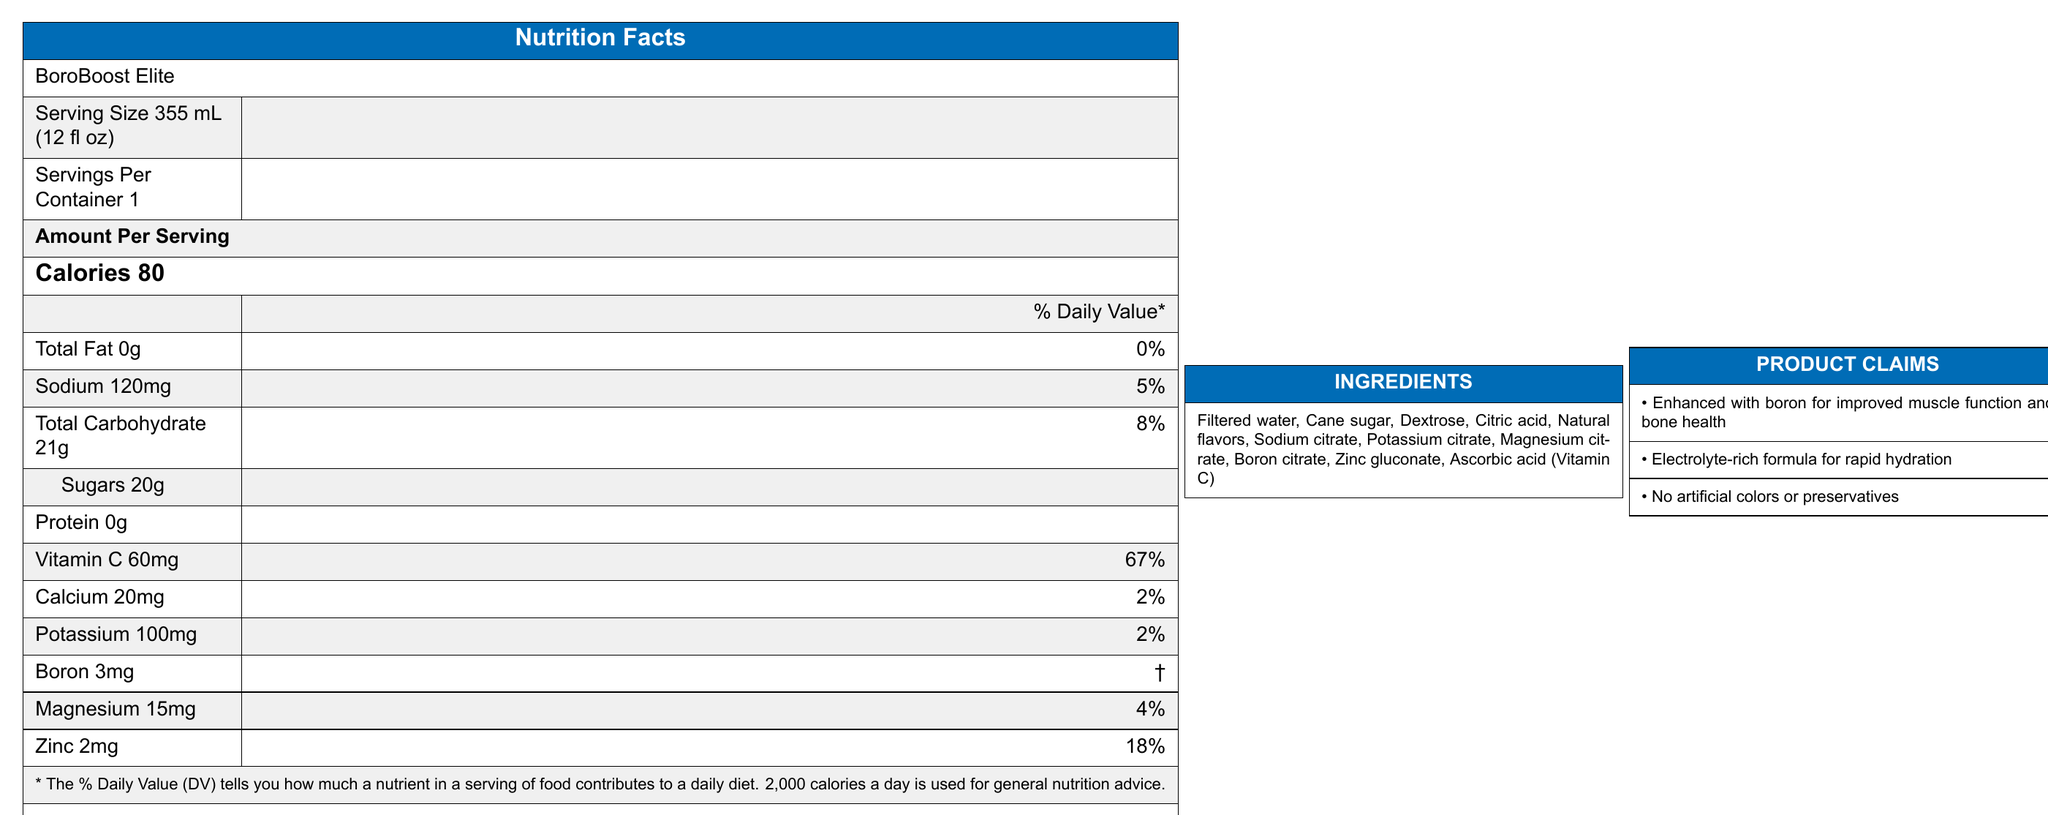what is the serving size for BoroBoost Elite? The serving size is explicitly stated as "Serving Size 355 mL (12 fl oz)" in the label.
Answer: 355 mL (12 fl oz) how many calories are there per serving? The label shows "Calories 80" under the "Amount Per Serving" section.
Answer: 80 calories what percentage of the Daily Value for sodium does one serving contain? The "Sodium 120mg" section lists "5%" as the Daily Value percentage.
Answer: 5% which mineral in BoroBoost Elite does not have an established Daily Value? A. Boron B. Magnesium C. Zinc D. Calcium The label indicates a "†" next to Boron 3mg, which is described as "Daily Value not established".
Answer: A. Boron how much vitamin C is in one serving? The label lists "Vitamin C 60mg" under the nutrients section.
Answer: 60mg does BoroBoost Elite contain any artificial colors? One of the product claims explicitly states "No artificial colors."
Answer: No what ingredients contribute to the electrolytes in the drink? The ingredients list includes electrolytes like sodium citrate, potassium citrate, and magnesium citrate.
Answer: Sodium citrate, Potassium citrate, Magnesium citrate which nutrient contributes the highest percentage of the Daily Value? A. Sodium B. Vitamin C C. Magnesium D. Zinc Vitamin C contributes 67% of the Daily Value, which is the highest among the listed nutrients.
Answer: B. Vitamin C is BoroBoost Elite FDA compliant? The regulatory compliance section states that it is "Compliant with FDA labeling requirements."
Answer: Yes describe the main features of the BoroBoost Elite label. The document details various features of BoroBoost Elite, including nutritional content, ingredients, product claims, and regulatory compliance.
Answer: BoroBoost Elite is a boron-enriched sports drink with a serving size of 355 mL, containing 80 calories per serving. The drink includes key minerals such as sodium, potassium, magnesium, and boron. It claims to enhance muscle function, provide rapid hydration, and contains no artificial colors or preservatives. It is FDA compliant and has a patent pending for the boron-enriched formulation. what is the unique selling point of BoroBoost Elite compared to other sports drinks? The competitor insights section highlights that the unique selling point of BoroBoost Elite is that it's the first sports drink with added boron.
Answer: First sports drink in the market with added boron what is the target audience for BoroBoost Elite? The competitor insights section lists the target audience as "Endurance athletes and fitness enthusiasts."
Answer: Endurance athletes and fitness enthusiasts how does BoroBoost Elite enhance athletic performance? One of the product claims states that the drink is "Enhanced with boron for improved muscle function and bone health."
Answer: Enhanced with boron for improved muscle function and bone health how does Erin Ventures' market share potentially get impacted by BoroBoost Elite? The document only mentions that BoroBoost Elite may impact Erin Ventures' boron market share but does not provide specific details on how it will do so.
Answer: Cannot be determined 